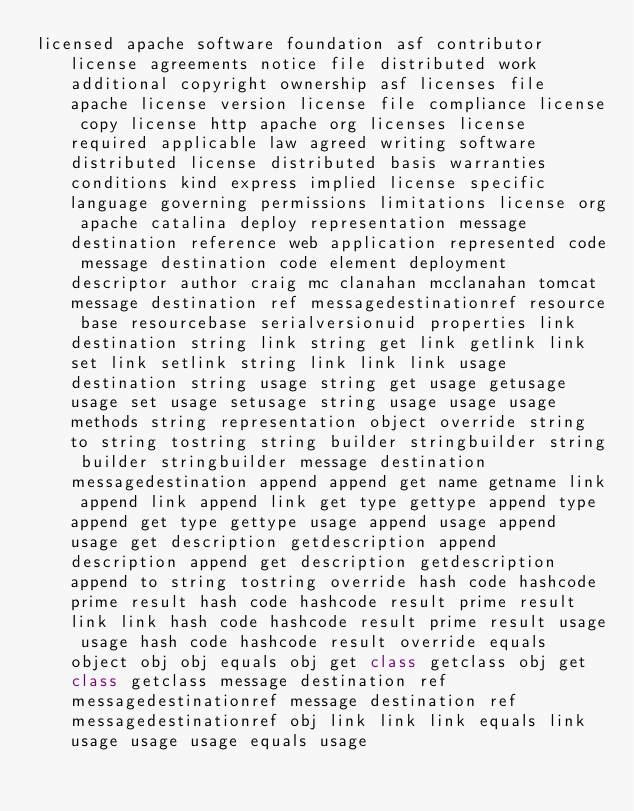Convert code to text. <code><loc_0><loc_0><loc_500><loc_500><_Java_>licensed apache software foundation asf contributor license agreements notice file distributed work additional copyright ownership asf licenses file apache license version license file compliance license copy license http apache org licenses license required applicable law agreed writing software distributed license distributed basis warranties conditions kind express implied license specific language governing permissions limitations license org apache catalina deploy representation message destination reference web application represented code message destination code element deployment descriptor author craig mc clanahan mcclanahan tomcat message destination ref messagedestinationref resource base resourcebase serialversionuid properties link destination string link string get link getlink link set link setlink string link link link usage destination string usage string get usage getusage usage set usage setusage string usage usage usage methods string representation object override string to string tostring string builder stringbuilder string builder stringbuilder message destination messagedestination append append get name getname link append link append link get type gettype append type append get type gettype usage append usage append usage get description getdescription append description append get description getdescription append to string tostring override hash code hashcode prime result hash code hashcode result prime result link link hash code hashcode result prime result usage usage hash code hashcode result override equals object obj obj equals obj get class getclass obj get class getclass message destination ref messagedestinationref message destination ref messagedestinationref obj link link link equals link usage usage usage equals usage</code> 